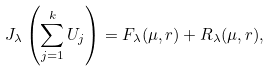Convert formula to latex. <formula><loc_0><loc_0><loc_500><loc_500>J _ { \lambda } \left ( \sum _ { j = 1 } ^ { k } U _ { j } \right ) = F _ { \lambda } ( \mu , r ) + R _ { \lambda } ( \mu , r ) ,</formula> 